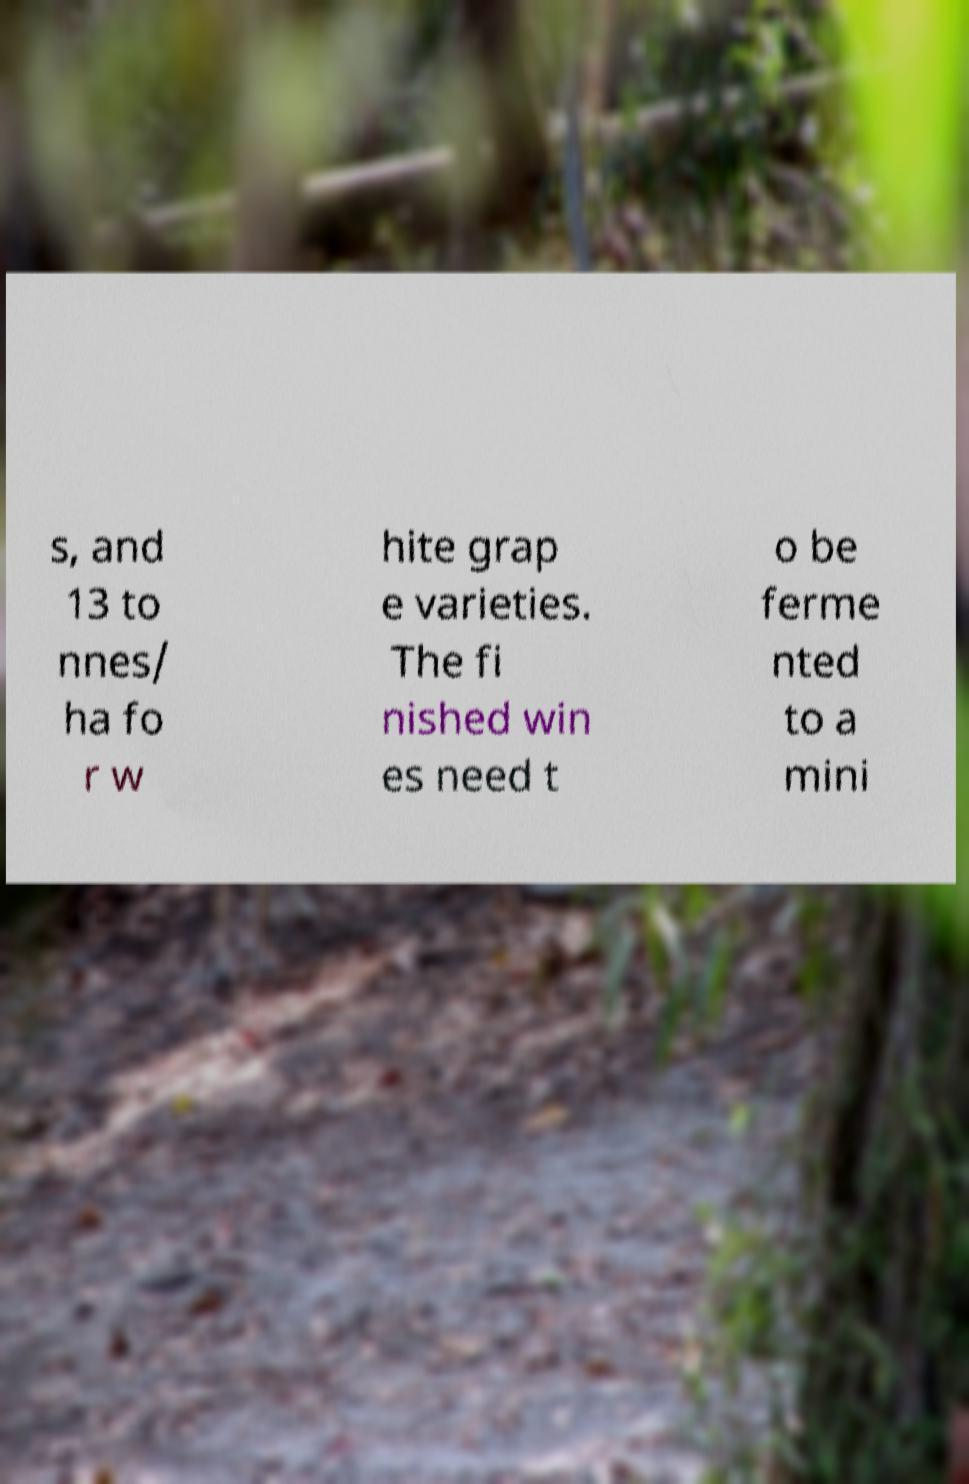I need the written content from this picture converted into text. Can you do that? The visible text in the image reads, 's, and 13 to nnes/ ha for white grape varieties. The finished wines need to be ferme nted to a mini.' However, the text starts and ends abruptly, indicating that there is missing context both before and after the provided segments. It appears to discuss the production or yield of white grape varieties and some requirements for wine fermentation. 